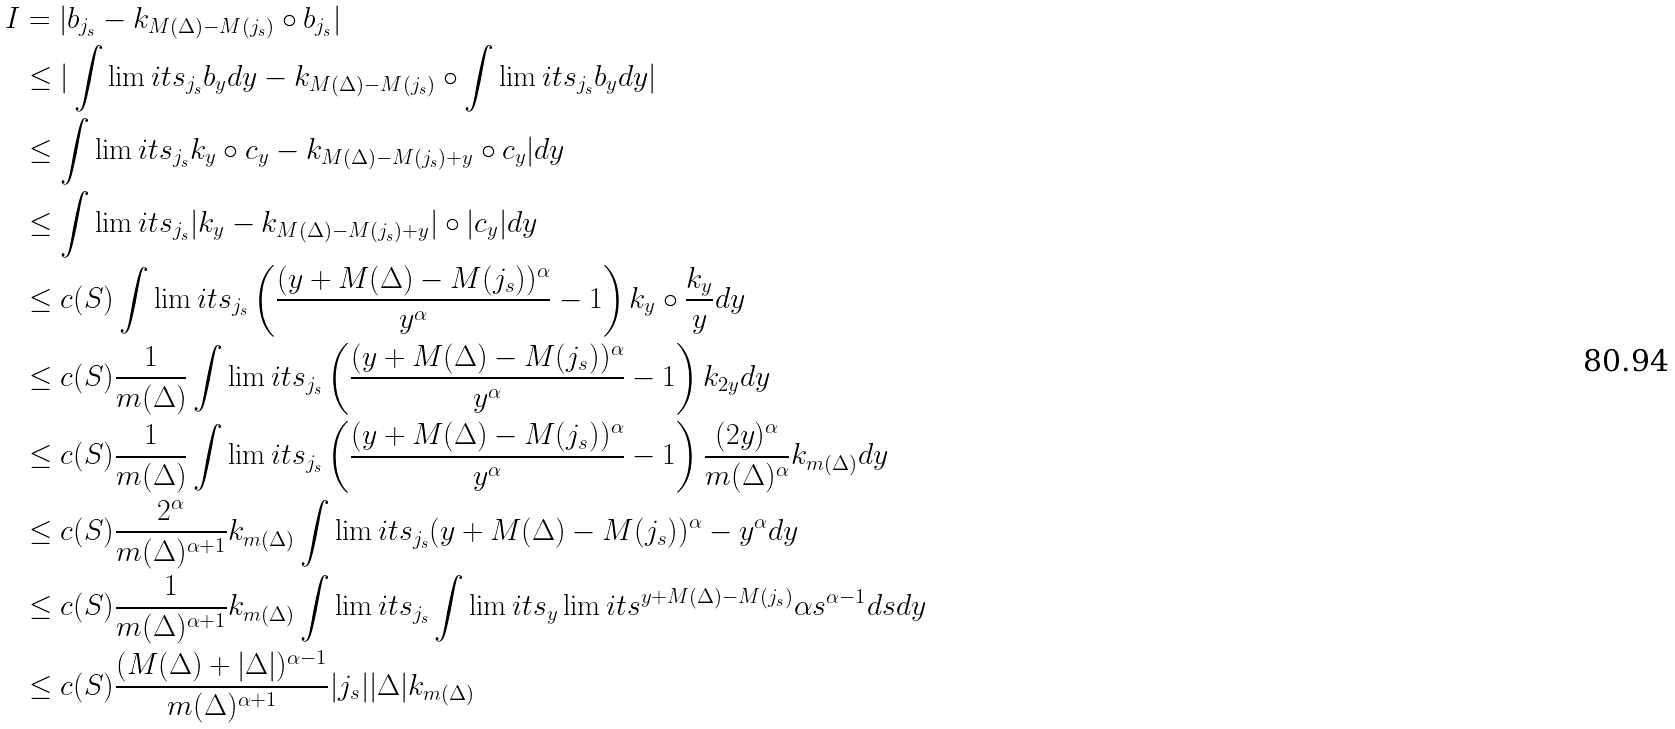<formula> <loc_0><loc_0><loc_500><loc_500>I & = | b _ { j _ { s } } - k _ { M ( \Delta ) - M ( j _ { s } ) } \circ b _ { j _ { s } } | \\ & \leq | \int \lim i t s _ { j _ { s } } b _ { y } d y - k _ { M ( \Delta ) - M ( j _ { s } ) } \circ \int \lim i t s _ { j _ { s } } b _ { y } d y | \\ & \leq \int \lim i t s _ { j _ { s } } k _ { y } \circ c _ { y } - k _ { M ( \Delta ) - M ( j _ { s } ) + y } \circ c _ { y } | d y \\ & \leq \int \lim i t s _ { j _ { s } } | k _ { y } - k _ { M ( \Delta ) - M ( j _ { s } ) + y } | \circ | c _ { y } | d y \\ & \leq c ( S ) \int \lim i t s _ { j _ { s } } \left ( \frac { ( y + M ( \Delta ) - M ( j _ { s } ) ) ^ { \alpha } } { y ^ { \alpha } } - 1 \right ) k _ { y } \circ \frac { k _ { y } } { y } d y \\ & \leq c ( S ) \frac { 1 } { m ( \Delta ) } \int \lim i t s _ { j _ { s } } \left ( \frac { ( y + M ( \Delta ) - M ( j _ { s } ) ) ^ { \alpha } } { y ^ { \alpha } } - 1 \right ) k _ { 2 y } d y \\ & \leq c ( S ) \frac { 1 } { m ( \Delta ) } \int \lim i t s _ { j _ { s } } \left ( \frac { ( y + M ( \Delta ) - M ( j _ { s } ) ) ^ { \alpha } } { y ^ { \alpha } } - 1 \right ) \frac { ( 2 y ) ^ { \alpha } } { m ( \Delta ) ^ { \alpha } } k _ { m ( \Delta ) } d y \\ & \leq c ( S ) \frac { 2 ^ { \alpha } } { m ( \Delta ) ^ { \alpha + 1 } } k _ { m ( \Delta ) } \int \lim i t s _ { j _ { s } } ( y + M ( \Delta ) - M ( j _ { s } ) ) ^ { \alpha } - y ^ { \alpha } d y \\ & \leq c ( S ) \frac { 1 } { m ( \Delta ) ^ { \alpha + 1 } } k _ { m ( \Delta ) } \int \lim i t s _ { j _ { s } } \int \lim i t s _ { y } \lim i t s ^ { y + M ( \Delta ) - M ( j _ { s } ) } \alpha s ^ { \alpha - 1 } d s d y \\ & \leq c ( S ) \frac { ( M ( \Delta ) + | \Delta | ) ^ { \alpha - 1 } } { m ( \Delta ) ^ { \alpha + 1 } } | j _ { s } | | \Delta | k _ { m ( \Delta ) }</formula> 